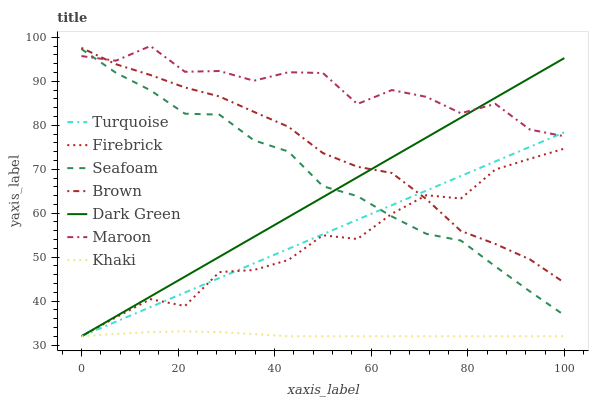Does Khaki have the minimum area under the curve?
Answer yes or no. Yes. Does Maroon have the maximum area under the curve?
Answer yes or no. Yes. Does Turquoise have the minimum area under the curve?
Answer yes or no. No. Does Turquoise have the maximum area under the curve?
Answer yes or no. No. Is Dark Green the smoothest?
Answer yes or no. Yes. Is Maroon the roughest?
Answer yes or no. Yes. Is Turquoise the smoothest?
Answer yes or no. No. Is Turquoise the roughest?
Answer yes or no. No. Does Seafoam have the lowest value?
Answer yes or no. No. Does Maroon have the highest value?
Answer yes or no. Yes. Does Turquoise have the highest value?
Answer yes or no. No. Is Khaki less than Brown?
Answer yes or no. Yes. Is Seafoam greater than Khaki?
Answer yes or no. Yes. Does Khaki intersect Brown?
Answer yes or no. No. 